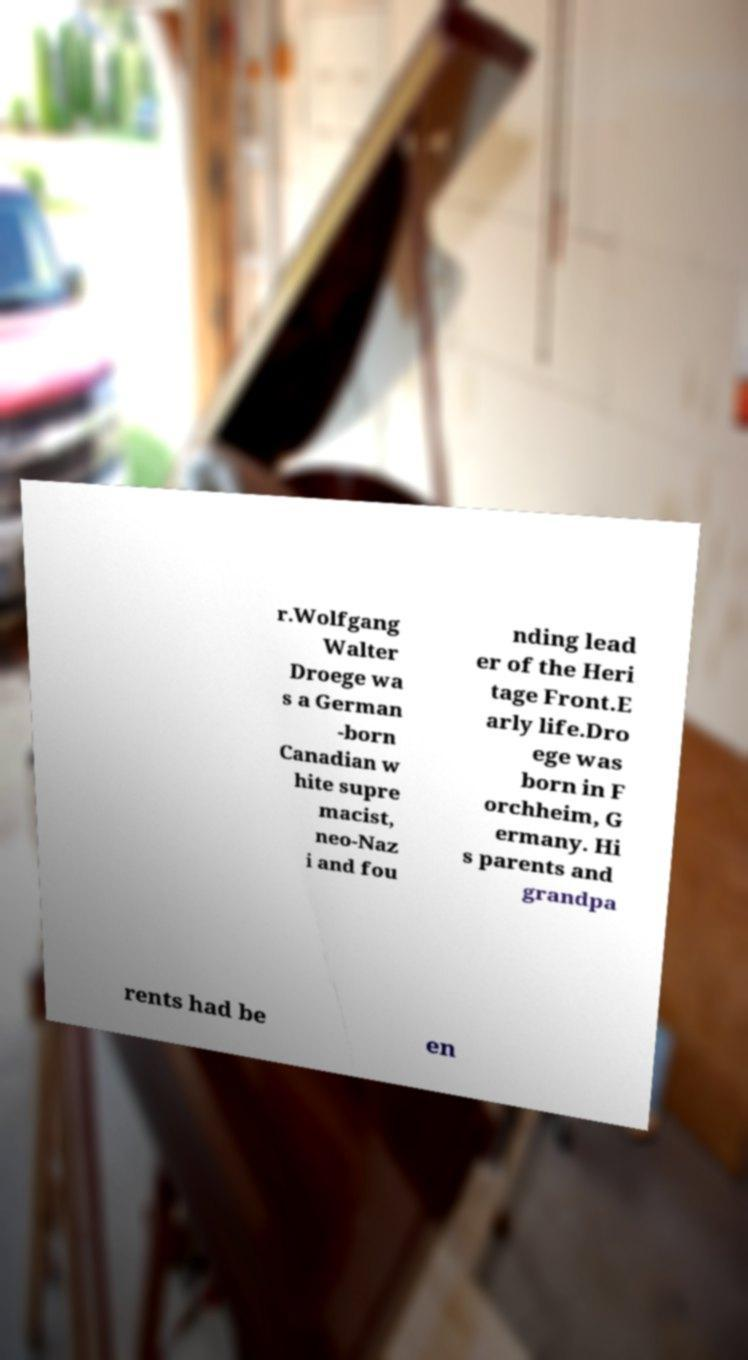What messages or text are displayed in this image? I need them in a readable, typed format. r.Wolfgang Walter Droege wa s a German -born Canadian w hite supre macist, neo-Naz i and fou nding lead er of the Heri tage Front.E arly life.Dro ege was born in F orchheim, G ermany. Hi s parents and grandpa rents had be en 